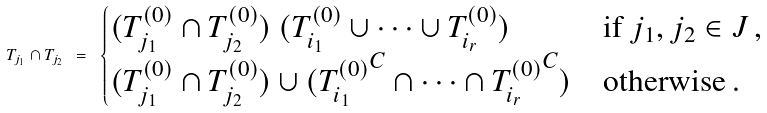<formula> <loc_0><loc_0><loc_500><loc_500>T _ { j _ { 1 } } \cap T _ { j _ { 2 } } \ = \ \begin{cases} ( T ^ { ( 0 ) } _ { j _ { 1 } } \cap T ^ { ( 0 ) } _ { j _ { 2 } } ) \ ( T ^ { ( 0 ) } _ { i _ { 1 } } \cup \cdots \cup T ^ { ( 0 ) } _ { i _ { r } } ) & \text {if $j_{1},j_{2}\in J$} \, , \\ ( T ^ { ( 0 ) } _ { j _ { 1 } } \cap T ^ { ( 0 ) } _ { j _ { 2 } } ) \cup ( { T ^ { ( 0 ) } _ { i _ { 1 } } } ^ { C } \cap \cdots \cap { T ^ { ( 0 ) } _ { i _ { r } } } ^ { C } ) & \text {otherwise} \, . \end{cases}</formula> 